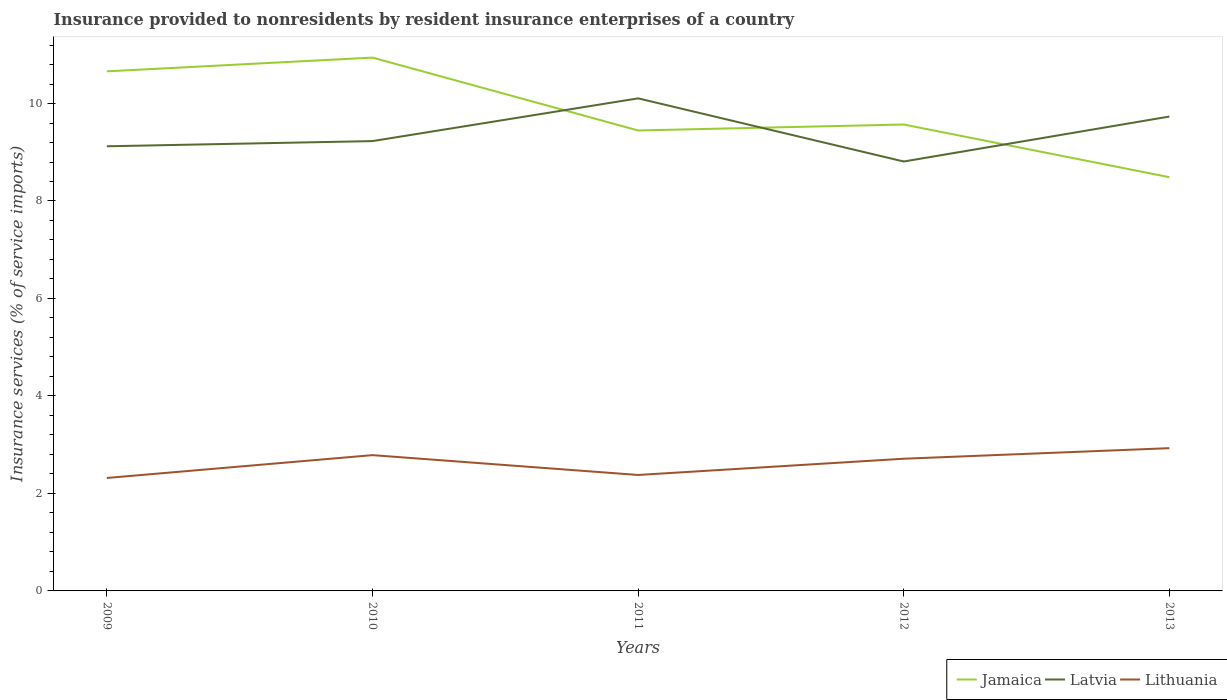How many different coloured lines are there?
Make the answer very short. 3. Is the number of lines equal to the number of legend labels?
Provide a succinct answer. Yes. Across all years, what is the maximum insurance provided to nonresidents in Jamaica?
Your response must be concise. 8.49. What is the total insurance provided to nonresidents in Latvia in the graph?
Give a very brief answer. 1.3. What is the difference between the highest and the second highest insurance provided to nonresidents in Lithuania?
Ensure brevity in your answer.  0.61. What is the difference between the highest and the lowest insurance provided to nonresidents in Lithuania?
Your answer should be very brief. 3. Does the graph contain grids?
Ensure brevity in your answer.  No. Where does the legend appear in the graph?
Your answer should be very brief. Bottom right. What is the title of the graph?
Your answer should be compact. Insurance provided to nonresidents by resident insurance enterprises of a country. Does "South Sudan" appear as one of the legend labels in the graph?
Keep it short and to the point. No. What is the label or title of the X-axis?
Give a very brief answer. Years. What is the label or title of the Y-axis?
Ensure brevity in your answer.  Insurance services (% of service imports). What is the Insurance services (% of service imports) of Jamaica in 2009?
Offer a terse response. 10.66. What is the Insurance services (% of service imports) of Latvia in 2009?
Provide a short and direct response. 9.12. What is the Insurance services (% of service imports) in Lithuania in 2009?
Make the answer very short. 2.32. What is the Insurance services (% of service imports) in Jamaica in 2010?
Your answer should be compact. 10.94. What is the Insurance services (% of service imports) of Latvia in 2010?
Give a very brief answer. 9.23. What is the Insurance services (% of service imports) of Lithuania in 2010?
Offer a terse response. 2.79. What is the Insurance services (% of service imports) in Jamaica in 2011?
Offer a very short reply. 9.45. What is the Insurance services (% of service imports) in Latvia in 2011?
Keep it short and to the point. 10.11. What is the Insurance services (% of service imports) of Lithuania in 2011?
Keep it short and to the point. 2.38. What is the Insurance services (% of service imports) of Jamaica in 2012?
Keep it short and to the point. 9.57. What is the Insurance services (% of service imports) of Latvia in 2012?
Provide a succinct answer. 8.81. What is the Insurance services (% of service imports) of Lithuania in 2012?
Provide a succinct answer. 2.71. What is the Insurance services (% of service imports) of Jamaica in 2013?
Offer a very short reply. 8.49. What is the Insurance services (% of service imports) in Latvia in 2013?
Offer a terse response. 9.73. What is the Insurance services (% of service imports) of Lithuania in 2013?
Give a very brief answer. 2.93. Across all years, what is the maximum Insurance services (% of service imports) of Jamaica?
Ensure brevity in your answer.  10.94. Across all years, what is the maximum Insurance services (% of service imports) in Latvia?
Provide a short and direct response. 10.11. Across all years, what is the maximum Insurance services (% of service imports) of Lithuania?
Keep it short and to the point. 2.93. Across all years, what is the minimum Insurance services (% of service imports) in Jamaica?
Give a very brief answer. 8.49. Across all years, what is the minimum Insurance services (% of service imports) of Latvia?
Offer a terse response. 8.81. Across all years, what is the minimum Insurance services (% of service imports) of Lithuania?
Offer a terse response. 2.32. What is the total Insurance services (% of service imports) of Jamaica in the graph?
Your response must be concise. 49.11. What is the total Insurance services (% of service imports) of Latvia in the graph?
Give a very brief answer. 47. What is the total Insurance services (% of service imports) in Lithuania in the graph?
Provide a short and direct response. 13.12. What is the difference between the Insurance services (% of service imports) in Jamaica in 2009 and that in 2010?
Offer a very short reply. -0.28. What is the difference between the Insurance services (% of service imports) in Latvia in 2009 and that in 2010?
Keep it short and to the point. -0.11. What is the difference between the Insurance services (% of service imports) of Lithuania in 2009 and that in 2010?
Keep it short and to the point. -0.47. What is the difference between the Insurance services (% of service imports) in Jamaica in 2009 and that in 2011?
Provide a short and direct response. 1.21. What is the difference between the Insurance services (% of service imports) of Latvia in 2009 and that in 2011?
Your response must be concise. -0.98. What is the difference between the Insurance services (% of service imports) of Lithuania in 2009 and that in 2011?
Your response must be concise. -0.06. What is the difference between the Insurance services (% of service imports) of Jamaica in 2009 and that in 2012?
Provide a succinct answer. 1.09. What is the difference between the Insurance services (% of service imports) in Latvia in 2009 and that in 2012?
Offer a very short reply. 0.31. What is the difference between the Insurance services (% of service imports) of Lithuania in 2009 and that in 2012?
Keep it short and to the point. -0.39. What is the difference between the Insurance services (% of service imports) of Jamaica in 2009 and that in 2013?
Give a very brief answer. 2.17. What is the difference between the Insurance services (% of service imports) of Latvia in 2009 and that in 2013?
Provide a short and direct response. -0.61. What is the difference between the Insurance services (% of service imports) of Lithuania in 2009 and that in 2013?
Your answer should be compact. -0.61. What is the difference between the Insurance services (% of service imports) in Jamaica in 2010 and that in 2011?
Give a very brief answer. 1.5. What is the difference between the Insurance services (% of service imports) in Latvia in 2010 and that in 2011?
Your response must be concise. -0.88. What is the difference between the Insurance services (% of service imports) of Lithuania in 2010 and that in 2011?
Ensure brevity in your answer.  0.41. What is the difference between the Insurance services (% of service imports) in Jamaica in 2010 and that in 2012?
Make the answer very short. 1.37. What is the difference between the Insurance services (% of service imports) of Latvia in 2010 and that in 2012?
Provide a succinct answer. 0.42. What is the difference between the Insurance services (% of service imports) in Lithuania in 2010 and that in 2012?
Ensure brevity in your answer.  0.07. What is the difference between the Insurance services (% of service imports) in Jamaica in 2010 and that in 2013?
Offer a very short reply. 2.45. What is the difference between the Insurance services (% of service imports) in Latvia in 2010 and that in 2013?
Provide a short and direct response. -0.5. What is the difference between the Insurance services (% of service imports) in Lithuania in 2010 and that in 2013?
Offer a very short reply. -0.14. What is the difference between the Insurance services (% of service imports) in Jamaica in 2011 and that in 2012?
Offer a terse response. -0.12. What is the difference between the Insurance services (% of service imports) in Latvia in 2011 and that in 2012?
Offer a very short reply. 1.3. What is the difference between the Insurance services (% of service imports) in Lithuania in 2011 and that in 2012?
Ensure brevity in your answer.  -0.33. What is the difference between the Insurance services (% of service imports) of Jamaica in 2011 and that in 2013?
Offer a very short reply. 0.96. What is the difference between the Insurance services (% of service imports) of Latvia in 2011 and that in 2013?
Provide a succinct answer. 0.37. What is the difference between the Insurance services (% of service imports) of Lithuania in 2011 and that in 2013?
Provide a short and direct response. -0.55. What is the difference between the Insurance services (% of service imports) of Jamaica in 2012 and that in 2013?
Keep it short and to the point. 1.08. What is the difference between the Insurance services (% of service imports) of Latvia in 2012 and that in 2013?
Make the answer very short. -0.92. What is the difference between the Insurance services (% of service imports) in Lithuania in 2012 and that in 2013?
Keep it short and to the point. -0.22. What is the difference between the Insurance services (% of service imports) of Jamaica in 2009 and the Insurance services (% of service imports) of Latvia in 2010?
Give a very brief answer. 1.43. What is the difference between the Insurance services (% of service imports) of Jamaica in 2009 and the Insurance services (% of service imports) of Lithuania in 2010?
Ensure brevity in your answer.  7.87. What is the difference between the Insurance services (% of service imports) of Latvia in 2009 and the Insurance services (% of service imports) of Lithuania in 2010?
Keep it short and to the point. 6.34. What is the difference between the Insurance services (% of service imports) of Jamaica in 2009 and the Insurance services (% of service imports) of Latvia in 2011?
Make the answer very short. 0.55. What is the difference between the Insurance services (% of service imports) in Jamaica in 2009 and the Insurance services (% of service imports) in Lithuania in 2011?
Keep it short and to the point. 8.28. What is the difference between the Insurance services (% of service imports) in Latvia in 2009 and the Insurance services (% of service imports) in Lithuania in 2011?
Your answer should be compact. 6.74. What is the difference between the Insurance services (% of service imports) in Jamaica in 2009 and the Insurance services (% of service imports) in Latvia in 2012?
Provide a short and direct response. 1.85. What is the difference between the Insurance services (% of service imports) in Jamaica in 2009 and the Insurance services (% of service imports) in Lithuania in 2012?
Your response must be concise. 7.95. What is the difference between the Insurance services (% of service imports) of Latvia in 2009 and the Insurance services (% of service imports) of Lithuania in 2012?
Provide a short and direct response. 6.41. What is the difference between the Insurance services (% of service imports) of Jamaica in 2009 and the Insurance services (% of service imports) of Latvia in 2013?
Offer a terse response. 0.93. What is the difference between the Insurance services (% of service imports) in Jamaica in 2009 and the Insurance services (% of service imports) in Lithuania in 2013?
Offer a terse response. 7.73. What is the difference between the Insurance services (% of service imports) in Latvia in 2009 and the Insurance services (% of service imports) in Lithuania in 2013?
Keep it short and to the point. 6.19. What is the difference between the Insurance services (% of service imports) of Jamaica in 2010 and the Insurance services (% of service imports) of Latvia in 2011?
Your answer should be compact. 0.84. What is the difference between the Insurance services (% of service imports) in Jamaica in 2010 and the Insurance services (% of service imports) in Lithuania in 2011?
Offer a very short reply. 8.56. What is the difference between the Insurance services (% of service imports) of Latvia in 2010 and the Insurance services (% of service imports) of Lithuania in 2011?
Make the answer very short. 6.85. What is the difference between the Insurance services (% of service imports) of Jamaica in 2010 and the Insurance services (% of service imports) of Latvia in 2012?
Make the answer very short. 2.13. What is the difference between the Insurance services (% of service imports) in Jamaica in 2010 and the Insurance services (% of service imports) in Lithuania in 2012?
Provide a short and direct response. 8.23. What is the difference between the Insurance services (% of service imports) of Latvia in 2010 and the Insurance services (% of service imports) of Lithuania in 2012?
Offer a terse response. 6.52. What is the difference between the Insurance services (% of service imports) in Jamaica in 2010 and the Insurance services (% of service imports) in Latvia in 2013?
Provide a succinct answer. 1.21. What is the difference between the Insurance services (% of service imports) of Jamaica in 2010 and the Insurance services (% of service imports) of Lithuania in 2013?
Offer a terse response. 8.01. What is the difference between the Insurance services (% of service imports) of Latvia in 2010 and the Insurance services (% of service imports) of Lithuania in 2013?
Your answer should be compact. 6.3. What is the difference between the Insurance services (% of service imports) in Jamaica in 2011 and the Insurance services (% of service imports) in Latvia in 2012?
Keep it short and to the point. 0.64. What is the difference between the Insurance services (% of service imports) in Jamaica in 2011 and the Insurance services (% of service imports) in Lithuania in 2012?
Provide a short and direct response. 6.73. What is the difference between the Insurance services (% of service imports) of Latvia in 2011 and the Insurance services (% of service imports) of Lithuania in 2012?
Your answer should be very brief. 7.39. What is the difference between the Insurance services (% of service imports) in Jamaica in 2011 and the Insurance services (% of service imports) in Latvia in 2013?
Offer a terse response. -0.29. What is the difference between the Insurance services (% of service imports) of Jamaica in 2011 and the Insurance services (% of service imports) of Lithuania in 2013?
Ensure brevity in your answer.  6.52. What is the difference between the Insurance services (% of service imports) in Latvia in 2011 and the Insurance services (% of service imports) in Lithuania in 2013?
Your answer should be compact. 7.18. What is the difference between the Insurance services (% of service imports) in Jamaica in 2012 and the Insurance services (% of service imports) in Latvia in 2013?
Ensure brevity in your answer.  -0.16. What is the difference between the Insurance services (% of service imports) of Jamaica in 2012 and the Insurance services (% of service imports) of Lithuania in 2013?
Your answer should be compact. 6.64. What is the difference between the Insurance services (% of service imports) of Latvia in 2012 and the Insurance services (% of service imports) of Lithuania in 2013?
Keep it short and to the point. 5.88. What is the average Insurance services (% of service imports) of Jamaica per year?
Give a very brief answer. 9.82. What is the average Insurance services (% of service imports) of Lithuania per year?
Make the answer very short. 2.62. In the year 2009, what is the difference between the Insurance services (% of service imports) of Jamaica and Insurance services (% of service imports) of Latvia?
Offer a very short reply. 1.54. In the year 2009, what is the difference between the Insurance services (% of service imports) of Jamaica and Insurance services (% of service imports) of Lithuania?
Make the answer very short. 8.34. In the year 2009, what is the difference between the Insurance services (% of service imports) of Latvia and Insurance services (% of service imports) of Lithuania?
Keep it short and to the point. 6.8. In the year 2010, what is the difference between the Insurance services (% of service imports) of Jamaica and Insurance services (% of service imports) of Latvia?
Offer a very short reply. 1.71. In the year 2010, what is the difference between the Insurance services (% of service imports) of Jamaica and Insurance services (% of service imports) of Lithuania?
Give a very brief answer. 8.16. In the year 2010, what is the difference between the Insurance services (% of service imports) in Latvia and Insurance services (% of service imports) in Lithuania?
Your answer should be very brief. 6.44. In the year 2011, what is the difference between the Insurance services (% of service imports) in Jamaica and Insurance services (% of service imports) in Latvia?
Your answer should be compact. -0.66. In the year 2011, what is the difference between the Insurance services (% of service imports) of Jamaica and Insurance services (% of service imports) of Lithuania?
Your answer should be compact. 7.07. In the year 2011, what is the difference between the Insurance services (% of service imports) of Latvia and Insurance services (% of service imports) of Lithuania?
Offer a very short reply. 7.73. In the year 2012, what is the difference between the Insurance services (% of service imports) in Jamaica and Insurance services (% of service imports) in Latvia?
Keep it short and to the point. 0.76. In the year 2012, what is the difference between the Insurance services (% of service imports) of Jamaica and Insurance services (% of service imports) of Lithuania?
Offer a terse response. 6.86. In the year 2012, what is the difference between the Insurance services (% of service imports) in Latvia and Insurance services (% of service imports) in Lithuania?
Provide a short and direct response. 6.1. In the year 2013, what is the difference between the Insurance services (% of service imports) in Jamaica and Insurance services (% of service imports) in Latvia?
Provide a succinct answer. -1.24. In the year 2013, what is the difference between the Insurance services (% of service imports) in Jamaica and Insurance services (% of service imports) in Lithuania?
Offer a terse response. 5.56. In the year 2013, what is the difference between the Insurance services (% of service imports) in Latvia and Insurance services (% of service imports) in Lithuania?
Offer a very short reply. 6.8. What is the ratio of the Insurance services (% of service imports) of Jamaica in 2009 to that in 2010?
Provide a short and direct response. 0.97. What is the ratio of the Insurance services (% of service imports) in Latvia in 2009 to that in 2010?
Your response must be concise. 0.99. What is the ratio of the Insurance services (% of service imports) of Lithuania in 2009 to that in 2010?
Give a very brief answer. 0.83. What is the ratio of the Insurance services (% of service imports) in Jamaica in 2009 to that in 2011?
Give a very brief answer. 1.13. What is the ratio of the Insurance services (% of service imports) of Latvia in 2009 to that in 2011?
Your response must be concise. 0.9. What is the ratio of the Insurance services (% of service imports) of Lithuania in 2009 to that in 2011?
Your answer should be compact. 0.97. What is the ratio of the Insurance services (% of service imports) of Jamaica in 2009 to that in 2012?
Ensure brevity in your answer.  1.11. What is the ratio of the Insurance services (% of service imports) in Latvia in 2009 to that in 2012?
Offer a very short reply. 1.04. What is the ratio of the Insurance services (% of service imports) in Lithuania in 2009 to that in 2012?
Offer a very short reply. 0.85. What is the ratio of the Insurance services (% of service imports) in Jamaica in 2009 to that in 2013?
Provide a succinct answer. 1.26. What is the ratio of the Insurance services (% of service imports) of Latvia in 2009 to that in 2013?
Keep it short and to the point. 0.94. What is the ratio of the Insurance services (% of service imports) of Lithuania in 2009 to that in 2013?
Provide a succinct answer. 0.79. What is the ratio of the Insurance services (% of service imports) in Jamaica in 2010 to that in 2011?
Give a very brief answer. 1.16. What is the ratio of the Insurance services (% of service imports) in Latvia in 2010 to that in 2011?
Offer a terse response. 0.91. What is the ratio of the Insurance services (% of service imports) in Lithuania in 2010 to that in 2011?
Keep it short and to the point. 1.17. What is the ratio of the Insurance services (% of service imports) of Jamaica in 2010 to that in 2012?
Offer a terse response. 1.14. What is the ratio of the Insurance services (% of service imports) of Latvia in 2010 to that in 2012?
Your response must be concise. 1.05. What is the ratio of the Insurance services (% of service imports) in Lithuania in 2010 to that in 2012?
Keep it short and to the point. 1.03. What is the ratio of the Insurance services (% of service imports) of Jamaica in 2010 to that in 2013?
Your answer should be very brief. 1.29. What is the ratio of the Insurance services (% of service imports) of Latvia in 2010 to that in 2013?
Your response must be concise. 0.95. What is the ratio of the Insurance services (% of service imports) in Lithuania in 2010 to that in 2013?
Ensure brevity in your answer.  0.95. What is the ratio of the Insurance services (% of service imports) of Jamaica in 2011 to that in 2012?
Provide a succinct answer. 0.99. What is the ratio of the Insurance services (% of service imports) of Latvia in 2011 to that in 2012?
Your response must be concise. 1.15. What is the ratio of the Insurance services (% of service imports) of Lithuania in 2011 to that in 2012?
Ensure brevity in your answer.  0.88. What is the ratio of the Insurance services (% of service imports) of Jamaica in 2011 to that in 2013?
Provide a short and direct response. 1.11. What is the ratio of the Insurance services (% of service imports) in Latvia in 2011 to that in 2013?
Offer a terse response. 1.04. What is the ratio of the Insurance services (% of service imports) in Lithuania in 2011 to that in 2013?
Provide a short and direct response. 0.81. What is the ratio of the Insurance services (% of service imports) in Jamaica in 2012 to that in 2013?
Ensure brevity in your answer.  1.13. What is the ratio of the Insurance services (% of service imports) in Latvia in 2012 to that in 2013?
Provide a succinct answer. 0.91. What is the ratio of the Insurance services (% of service imports) in Lithuania in 2012 to that in 2013?
Ensure brevity in your answer.  0.93. What is the difference between the highest and the second highest Insurance services (% of service imports) of Jamaica?
Your answer should be compact. 0.28. What is the difference between the highest and the second highest Insurance services (% of service imports) of Latvia?
Ensure brevity in your answer.  0.37. What is the difference between the highest and the second highest Insurance services (% of service imports) of Lithuania?
Your response must be concise. 0.14. What is the difference between the highest and the lowest Insurance services (% of service imports) of Jamaica?
Your answer should be very brief. 2.45. What is the difference between the highest and the lowest Insurance services (% of service imports) of Latvia?
Provide a succinct answer. 1.3. What is the difference between the highest and the lowest Insurance services (% of service imports) of Lithuania?
Keep it short and to the point. 0.61. 